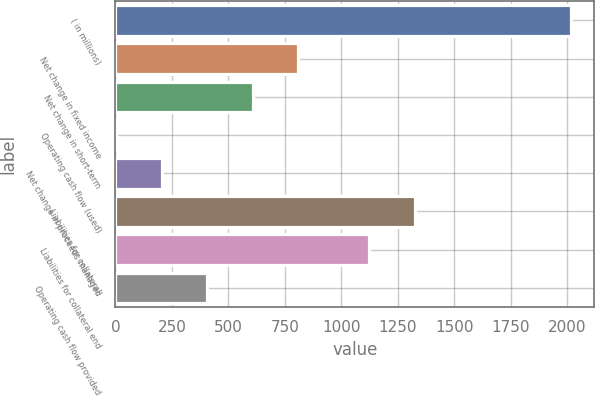<chart> <loc_0><loc_0><loc_500><loc_500><bar_chart><fcel>( in millions)<fcel>Net change in fixed income<fcel>Net change in short-term<fcel>Operating cash flow (used)<fcel>Net change in proceeds managed<fcel>Liabilities for collateral<fcel>Liabilities for collateral end<fcel>Operating cash flow provided<nl><fcel>2017<fcel>809.2<fcel>607.9<fcel>4<fcel>205.3<fcel>1325.3<fcel>1124<fcel>406.6<nl></chart> 